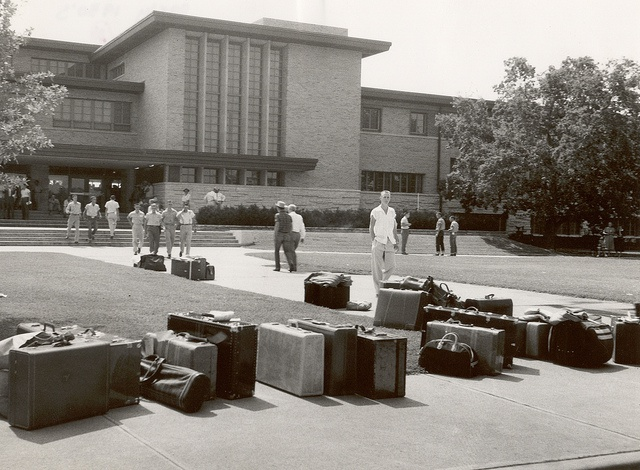Describe the objects in this image and their specific colors. I can see suitcase in darkgray, black, gray, and lightgray tones, suitcase in darkgray, black, and lightgray tones, suitcase in darkgray, gray, and lightgray tones, suitcase in darkgray, black, gray, and lightgray tones, and suitcase in darkgray, black, and gray tones in this image. 